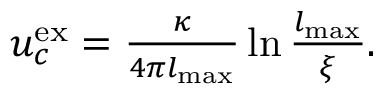Convert formula to latex. <formula><loc_0><loc_0><loc_500><loc_500>\begin{array} { r } { u _ { c } ^ { e x } = \frac { \kappa } { 4 \pi l _ { \max } } \ln \frac { l _ { \max } } { \xi } . } \end{array}</formula> 